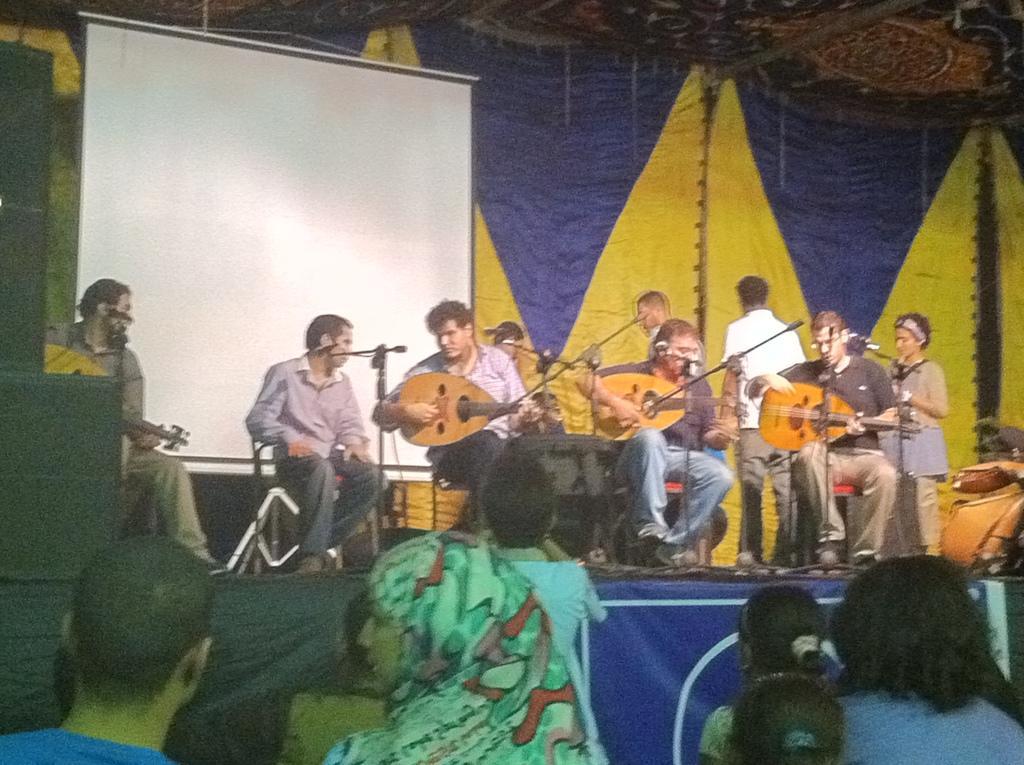Could you give a brief overview of what you see in this image? The picture is taken from a live concert. In the foreground of the picture there are people and kids. In the center of the picture there are people playing musical instruments, on a stage. On the stage there are microphones, speakers, people and projector screen. In the background there are curtains. At the top it is tent. 